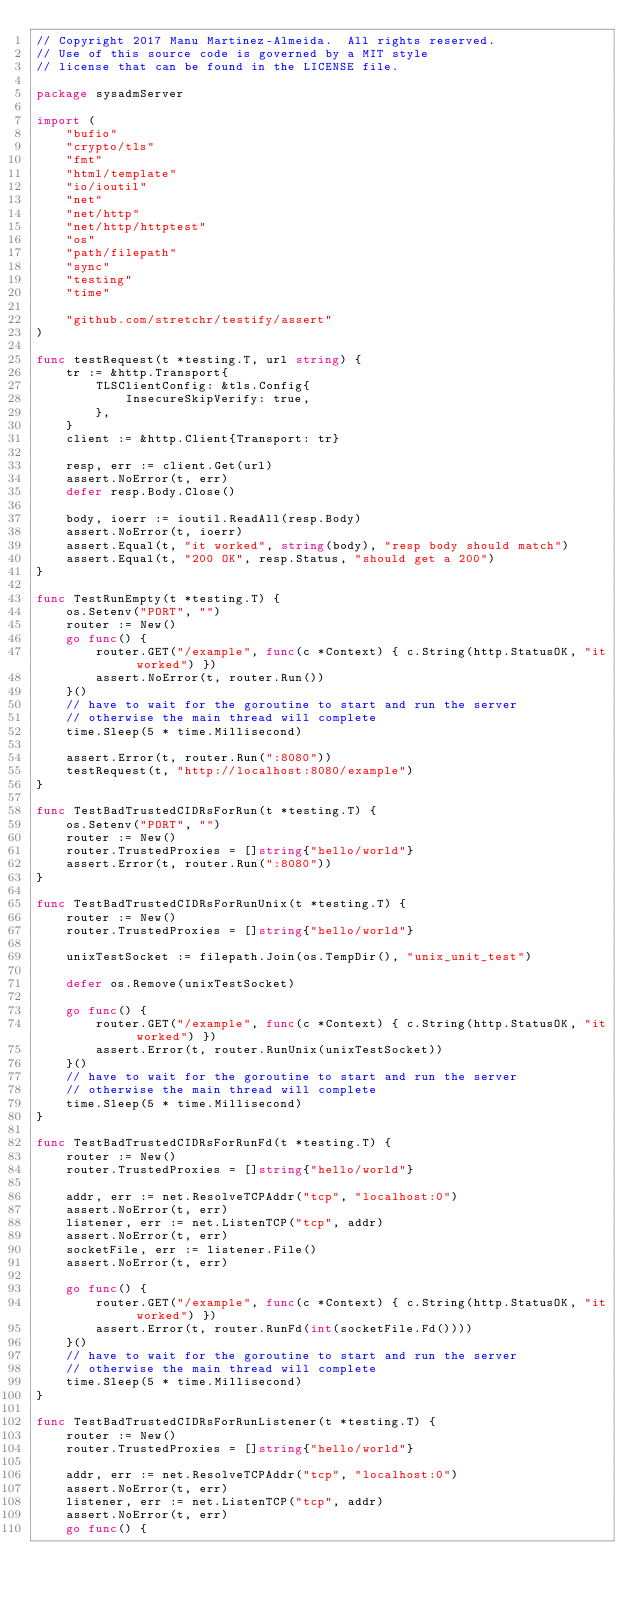Convert code to text. <code><loc_0><loc_0><loc_500><loc_500><_Go_>// Copyright 2017 Manu Martinez-Almeida.  All rights reserved.
// Use of this source code is governed by a MIT style
// license that can be found in the LICENSE file.

package sysadmServer

import (
	"bufio"
	"crypto/tls"
	"fmt"
	"html/template"
	"io/ioutil"
	"net"
	"net/http"
	"net/http/httptest"
	"os"
	"path/filepath"
	"sync"
	"testing"
	"time"

	"github.com/stretchr/testify/assert"
)

func testRequest(t *testing.T, url string) {
	tr := &http.Transport{
		TLSClientConfig: &tls.Config{
			InsecureSkipVerify: true,
		},
	}
	client := &http.Client{Transport: tr}

	resp, err := client.Get(url)
	assert.NoError(t, err)
	defer resp.Body.Close()

	body, ioerr := ioutil.ReadAll(resp.Body)
	assert.NoError(t, ioerr)
	assert.Equal(t, "it worked", string(body), "resp body should match")
	assert.Equal(t, "200 OK", resp.Status, "should get a 200")
}

func TestRunEmpty(t *testing.T) {
	os.Setenv("PORT", "")
	router := New()
	go func() {
		router.GET("/example", func(c *Context) { c.String(http.StatusOK, "it worked") })
		assert.NoError(t, router.Run())
	}()
	// have to wait for the goroutine to start and run the server
	// otherwise the main thread will complete
	time.Sleep(5 * time.Millisecond)

	assert.Error(t, router.Run(":8080"))
	testRequest(t, "http://localhost:8080/example")
}

func TestBadTrustedCIDRsForRun(t *testing.T) {
	os.Setenv("PORT", "")
	router := New()
	router.TrustedProxies = []string{"hello/world"}
	assert.Error(t, router.Run(":8080"))
}

func TestBadTrustedCIDRsForRunUnix(t *testing.T) {
	router := New()
	router.TrustedProxies = []string{"hello/world"}

	unixTestSocket := filepath.Join(os.TempDir(), "unix_unit_test")

	defer os.Remove(unixTestSocket)

	go func() {
		router.GET("/example", func(c *Context) { c.String(http.StatusOK, "it worked") })
		assert.Error(t, router.RunUnix(unixTestSocket))
	}()
	// have to wait for the goroutine to start and run the server
	// otherwise the main thread will complete
	time.Sleep(5 * time.Millisecond)
}

func TestBadTrustedCIDRsForRunFd(t *testing.T) {
	router := New()
	router.TrustedProxies = []string{"hello/world"}

	addr, err := net.ResolveTCPAddr("tcp", "localhost:0")
	assert.NoError(t, err)
	listener, err := net.ListenTCP("tcp", addr)
	assert.NoError(t, err)
	socketFile, err := listener.File()
	assert.NoError(t, err)

	go func() {
		router.GET("/example", func(c *Context) { c.String(http.StatusOK, "it worked") })
		assert.Error(t, router.RunFd(int(socketFile.Fd())))
	}()
	// have to wait for the goroutine to start and run the server
	// otherwise the main thread will complete
	time.Sleep(5 * time.Millisecond)
}

func TestBadTrustedCIDRsForRunListener(t *testing.T) {
	router := New()
	router.TrustedProxies = []string{"hello/world"}

	addr, err := net.ResolveTCPAddr("tcp", "localhost:0")
	assert.NoError(t, err)
	listener, err := net.ListenTCP("tcp", addr)
	assert.NoError(t, err)
	go func() {</code> 